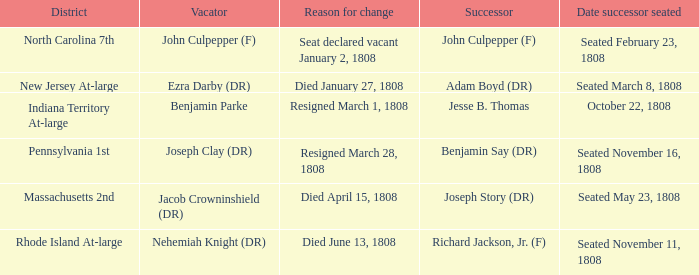What is the date successor seated where Massachusetts 2nd is the district? Seated May 23, 1808. 